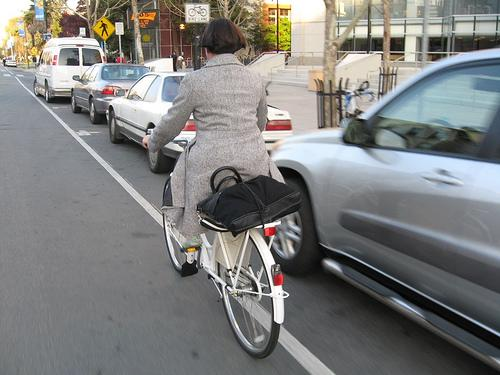What is the primary activity taking place in the image? A lady driving a bicycle in the street. Mention the type and color of the jacket the person is wearing while riding the bike. The person is wearing a long grey coat while riding the bike. List the objects and their colors found on the woman's bicycle. On the bicycle, there is a black bag, a white light, and red reflectors. What color and type of vehicles are parked on the side of the road? There is a parked white van and a parked white car behind the van. Which objects in the image can be described as having a light and what color is the light? There are two lights on the bike, and their colors are not mentioned. Mention the color of the bicycle and car in the image. The bicycle is white and there are two cars, one silvery and one white. Describe the road in terms of its surface and markings. The road has a black asphalt surface with a white line painted on it, and there is a line separating parking from the road. State the color of the leaves and the fence surrounding a tree. The leaves are green in color, and the fence surrounding the tree trunk is black. Describe the garbage cans and the sidewalk in terms of color and material. There are black garbage cans on the sidewalk, and the sidewalk has a grey concrete surface. Identify the color and type of the sign on the sidewalk. There is a yellow caution sign for pedestrians on the sidewalk. 